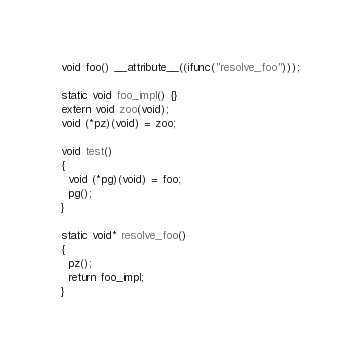<code> <loc_0><loc_0><loc_500><loc_500><_C_>void foo() __attribute__((ifunc("resolve_foo")));

static void foo_impl() {}
extern void zoo(void);
void (*pz)(void) = zoo;

void test()
{
  void (*pg)(void) = foo;
  pg();
}

static void* resolve_foo()
{
  pz();
  return foo_impl;
}
</code> 